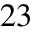<formula> <loc_0><loc_0><loc_500><loc_500>^ { 2 3 }</formula> 